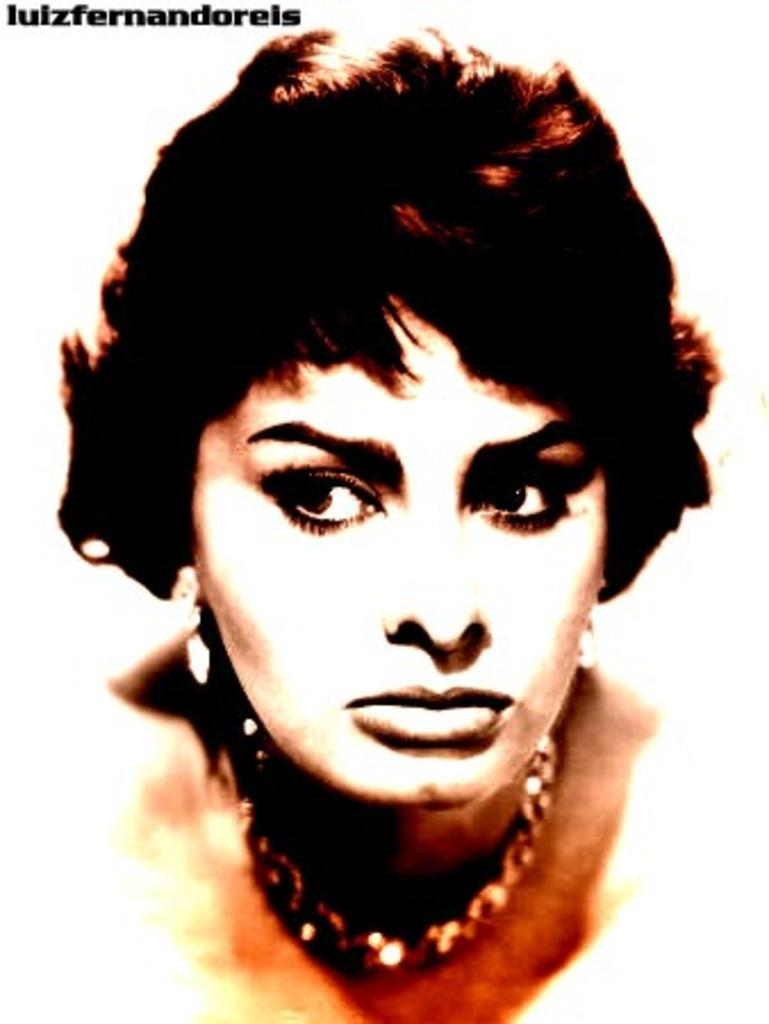What can be found in the image that contains written information? There is text in the image. What are the women in the image wearing? The women in the image are wearing ornaments. What color is the background of the image? The background of the image is white. What type of drink is being served in the image? There is no drink present in the image. Is there a scarecrow visible in the image? No, there is no scarecrow present in the image. 